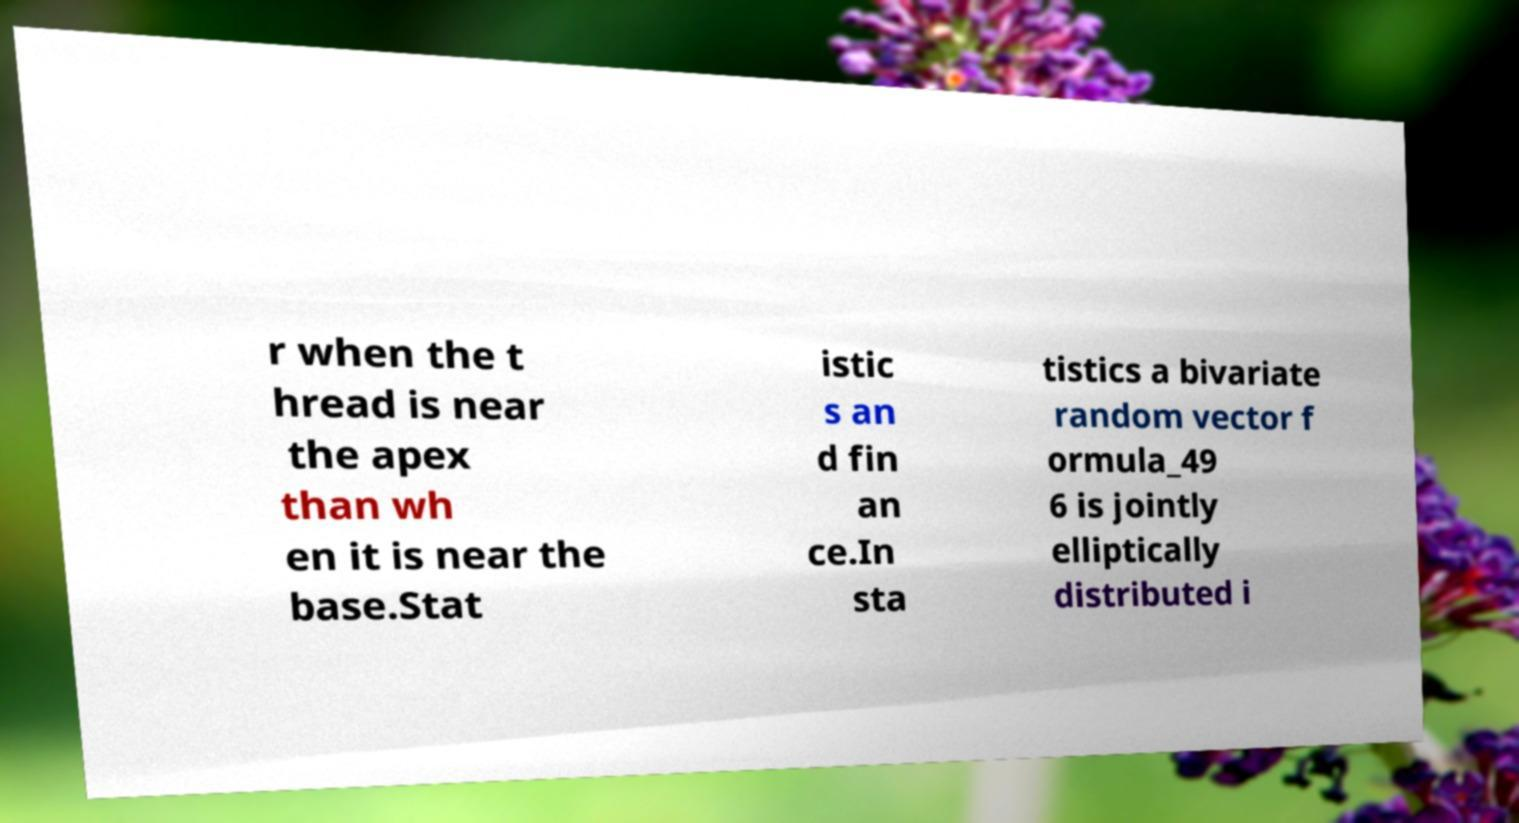Could you assist in decoding the text presented in this image and type it out clearly? r when the t hread is near the apex than wh en it is near the base.Stat istic s an d fin an ce.In sta tistics a bivariate random vector f ormula_49 6 is jointly elliptically distributed i 